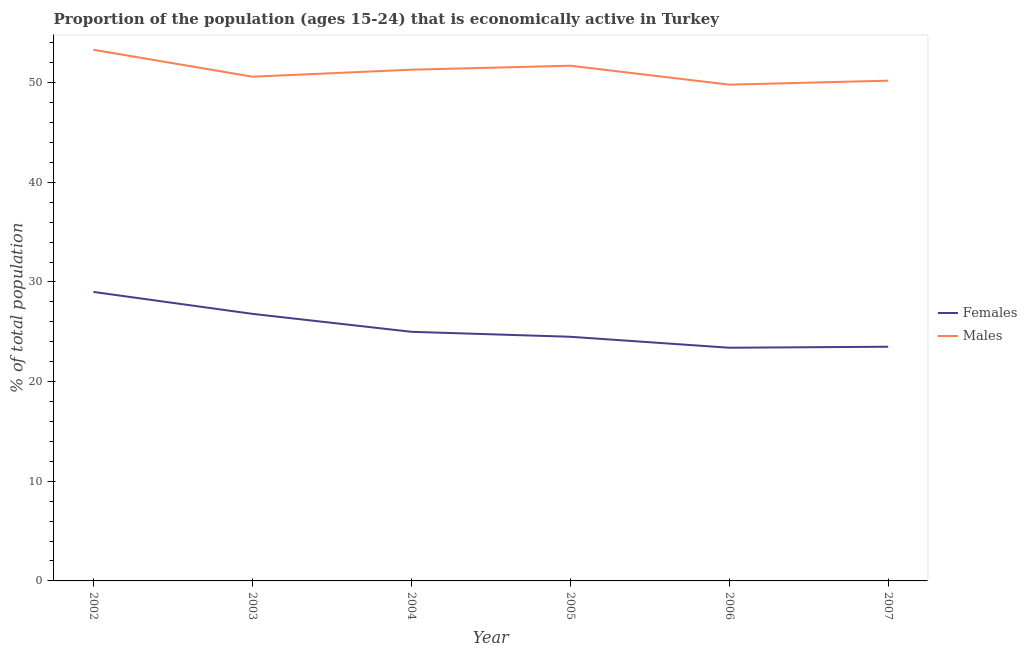How many different coloured lines are there?
Give a very brief answer. 2. Does the line corresponding to percentage of economically active male population intersect with the line corresponding to percentage of economically active female population?
Make the answer very short. No. Is the number of lines equal to the number of legend labels?
Offer a very short reply. Yes. What is the percentage of economically active male population in 2005?
Offer a very short reply. 51.7. Across all years, what is the maximum percentage of economically active female population?
Your answer should be compact. 29. Across all years, what is the minimum percentage of economically active female population?
Offer a terse response. 23.4. In which year was the percentage of economically active male population maximum?
Provide a succinct answer. 2002. In which year was the percentage of economically active female population minimum?
Provide a short and direct response. 2006. What is the total percentage of economically active female population in the graph?
Your answer should be very brief. 152.2. What is the difference between the percentage of economically active male population in 2003 and that in 2006?
Keep it short and to the point. 0.8. What is the difference between the percentage of economically active male population in 2005 and the percentage of economically active female population in 2006?
Your answer should be very brief. 28.3. What is the average percentage of economically active female population per year?
Offer a terse response. 25.37. In the year 2005, what is the difference between the percentage of economically active male population and percentage of economically active female population?
Make the answer very short. 27.2. What is the ratio of the percentage of economically active male population in 2003 to that in 2004?
Keep it short and to the point. 0.99. Is the percentage of economically active female population in 2002 less than that in 2005?
Ensure brevity in your answer.  No. What is the difference between the highest and the second highest percentage of economically active female population?
Offer a terse response. 2.2. In how many years, is the percentage of economically active male population greater than the average percentage of economically active male population taken over all years?
Give a very brief answer. 3. Is the sum of the percentage of economically active female population in 2006 and 2007 greater than the maximum percentage of economically active male population across all years?
Provide a short and direct response. No. Is the percentage of economically active male population strictly greater than the percentage of economically active female population over the years?
Your response must be concise. Yes. How many years are there in the graph?
Provide a succinct answer. 6. Are the values on the major ticks of Y-axis written in scientific E-notation?
Provide a short and direct response. No. Does the graph contain grids?
Ensure brevity in your answer.  No. How are the legend labels stacked?
Make the answer very short. Vertical. What is the title of the graph?
Offer a very short reply. Proportion of the population (ages 15-24) that is economically active in Turkey. What is the label or title of the X-axis?
Offer a terse response. Year. What is the label or title of the Y-axis?
Make the answer very short. % of total population. What is the % of total population in Females in 2002?
Provide a short and direct response. 29. What is the % of total population of Males in 2002?
Ensure brevity in your answer.  53.3. What is the % of total population of Females in 2003?
Your response must be concise. 26.8. What is the % of total population in Males in 2003?
Your answer should be very brief. 50.6. What is the % of total population of Males in 2004?
Offer a terse response. 51.3. What is the % of total population in Females in 2005?
Keep it short and to the point. 24.5. What is the % of total population of Males in 2005?
Your answer should be compact. 51.7. What is the % of total population in Females in 2006?
Offer a terse response. 23.4. What is the % of total population in Males in 2006?
Provide a succinct answer. 49.8. What is the % of total population in Males in 2007?
Ensure brevity in your answer.  50.2. Across all years, what is the maximum % of total population in Females?
Your answer should be compact. 29. Across all years, what is the maximum % of total population of Males?
Give a very brief answer. 53.3. Across all years, what is the minimum % of total population of Females?
Make the answer very short. 23.4. Across all years, what is the minimum % of total population of Males?
Your response must be concise. 49.8. What is the total % of total population in Females in the graph?
Your response must be concise. 152.2. What is the total % of total population in Males in the graph?
Your answer should be very brief. 306.9. What is the difference between the % of total population of Females in 2002 and that in 2004?
Give a very brief answer. 4. What is the difference between the % of total population in Males in 2002 and that in 2004?
Your answer should be very brief. 2. What is the difference between the % of total population of Females in 2002 and that in 2005?
Offer a very short reply. 4.5. What is the difference between the % of total population in Females in 2002 and that in 2006?
Your answer should be compact. 5.6. What is the difference between the % of total population in Males in 2002 and that in 2006?
Keep it short and to the point. 3.5. What is the difference between the % of total population in Females in 2002 and that in 2007?
Ensure brevity in your answer.  5.5. What is the difference between the % of total population of Males in 2002 and that in 2007?
Your answer should be very brief. 3.1. What is the difference between the % of total population of Males in 2003 and that in 2005?
Offer a very short reply. -1.1. What is the difference between the % of total population in Males in 2003 and that in 2006?
Your answer should be compact. 0.8. What is the difference between the % of total population in Males in 2003 and that in 2007?
Make the answer very short. 0.4. What is the difference between the % of total population in Males in 2004 and that in 2005?
Ensure brevity in your answer.  -0.4. What is the difference between the % of total population in Males in 2004 and that in 2006?
Give a very brief answer. 1.5. What is the difference between the % of total population of Males in 2004 and that in 2007?
Give a very brief answer. 1.1. What is the difference between the % of total population in Females in 2005 and that in 2006?
Make the answer very short. 1.1. What is the difference between the % of total population in Males in 2005 and that in 2006?
Keep it short and to the point. 1.9. What is the difference between the % of total population in Males in 2005 and that in 2007?
Offer a terse response. 1.5. What is the difference between the % of total population of Females in 2006 and that in 2007?
Provide a short and direct response. -0.1. What is the difference between the % of total population in Males in 2006 and that in 2007?
Keep it short and to the point. -0.4. What is the difference between the % of total population in Females in 2002 and the % of total population in Males in 2003?
Your answer should be compact. -21.6. What is the difference between the % of total population of Females in 2002 and the % of total population of Males in 2004?
Provide a succinct answer. -22.3. What is the difference between the % of total population in Females in 2002 and the % of total population in Males in 2005?
Give a very brief answer. -22.7. What is the difference between the % of total population in Females in 2002 and the % of total population in Males in 2006?
Give a very brief answer. -20.8. What is the difference between the % of total population in Females in 2002 and the % of total population in Males in 2007?
Your answer should be compact. -21.2. What is the difference between the % of total population of Females in 2003 and the % of total population of Males in 2004?
Your response must be concise. -24.5. What is the difference between the % of total population in Females in 2003 and the % of total population in Males in 2005?
Your answer should be compact. -24.9. What is the difference between the % of total population of Females in 2003 and the % of total population of Males in 2007?
Offer a very short reply. -23.4. What is the difference between the % of total population in Females in 2004 and the % of total population in Males in 2005?
Give a very brief answer. -26.7. What is the difference between the % of total population of Females in 2004 and the % of total population of Males in 2006?
Offer a very short reply. -24.8. What is the difference between the % of total population in Females in 2004 and the % of total population in Males in 2007?
Keep it short and to the point. -25.2. What is the difference between the % of total population in Females in 2005 and the % of total population in Males in 2006?
Keep it short and to the point. -25.3. What is the difference between the % of total population of Females in 2005 and the % of total population of Males in 2007?
Provide a short and direct response. -25.7. What is the difference between the % of total population in Females in 2006 and the % of total population in Males in 2007?
Ensure brevity in your answer.  -26.8. What is the average % of total population of Females per year?
Provide a succinct answer. 25.37. What is the average % of total population of Males per year?
Your answer should be compact. 51.15. In the year 2002, what is the difference between the % of total population of Females and % of total population of Males?
Offer a terse response. -24.3. In the year 2003, what is the difference between the % of total population of Females and % of total population of Males?
Your response must be concise. -23.8. In the year 2004, what is the difference between the % of total population in Females and % of total population in Males?
Offer a very short reply. -26.3. In the year 2005, what is the difference between the % of total population in Females and % of total population in Males?
Keep it short and to the point. -27.2. In the year 2006, what is the difference between the % of total population in Females and % of total population in Males?
Offer a terse response. -26.4. In the year 2007, what is the difference between the % of total population of Females and % of total population of Males?
Offer a terse response. -26.7. What is the ratio of the % of total population in Females in 2002 to that in 2003?
Give a very brief answer. 1.08. What is the ratio of the % of total population in Males in 2002 to that in 2003?
Make the answer very short. 1.05. What is the ratio of the % of total population of Females in 2002 to that in 2004?
Make the answer very short. 1.16. What is the ratio of the % of total population of Males in 2002 to that in 2004?
Provide a short and direct response. 1.04. What is the ratio of the % of total population of Females in 2002 to that in 2005?
Your answer should be very brief. 1.18. What is the ratio of the % of total population of Males in 2002 to that in 2005?
Provide a short and direct response. 1.03. What is the ratio of the % of total population in Females in 2002 to that in 2006?
Offer a very short reply. 1.24. What is the ratio of the % of total population of Males in 2002 to that in 2006?
Offer a very short reply. 1.07. What is the ratio of the % of total population in Females in 2002 to that in 2007?
Offer a very short reply. 1.23. What is the ratio of the % of total population of Males in 2002 to that in 2007?
Your answer should be very brief. 1.06. What is the ratio of the % of total population in Females in 2003 to that in 2004?
Give a very brief answer. 1.07. What is the ratio of the % of total population in Males in 2003 to that in 2004?
Your response must be concise. 0.99. What is the ratio of the % of total population in Females in 2003 to that in 2005?
Your answer should be very brief. 1.09. What is the ratio of the % of total population in Males in 2003 to that in 2005?
Make the answer very short. 0.98. What is the ratio of the % of total population of Females in 2003 to that in 2006?
Offer a terse response. 1.15. What is the ratio of the % of total population of Males in 2003 to that in 2006?
Keep it short and to the point. 1.02. What is the ratio of the % of total population in Females in 2003 to that in 2007?
Your answer should be very brief. 1.14. What is the ratio of the % of total population of Females in 2004 to that in 2005?
Provide a short and direct response. 1.02. What is the ratio of the % of total population of Females in 2004 to that in 2006?
Your answer should be compact. 1.07. What is the ratio of the % of total population in Males in 2004 to that in 2006?
Make the answer very short. 1.03. What is the ratio of the % of total population of Females in 2004 to that in 2007?
Provide a succinct answer. 1.06. What is the ratio of the % of total population in Males in 2004 to that in 2007?
Keep it short and to the point. 1.02. What is the ratio of the % of total population in Females in 2005 to that in 2006?
Provide a succinct answer. 1.05. What is the ratio of the % of total population in Males in 2005 to that in 2006?
Ensure brevity in your answer.  1.04. What is the ratio of the % of total population in Females in 2005 to that in 2007?
Make the answer very short. 1.04. What is the ratio of the % of total population of Males in 2005 to that in 2007?
Offer a very short reply. 1.03. What is the ratio of the % of total population of Males in 2006 to that in 2007?
Offer a terse response. 0.99. What is the difference between the highest and the second highest % of total population of Females?
Your answer should be compact. 2.2. What is the difference between the highest and the second highest % of total population in Males?
Make the answer very short. 1.6. What is the difference between the highest and the lowest % of total population of Females?
Provide a short and direct response. 5.6. 